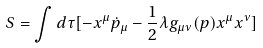Convert formula to latex. <formula><loc_0><loc_0><loc_500><loc_500>S = \int d \tau [ - x ^ { \mu } \dot { p } _ { \mu } - \frac { 1 } { 2 } \lambda g _ { \mu \nu } ( p ) x ^ { \mu } x ^ { \nu } ]</formula> 